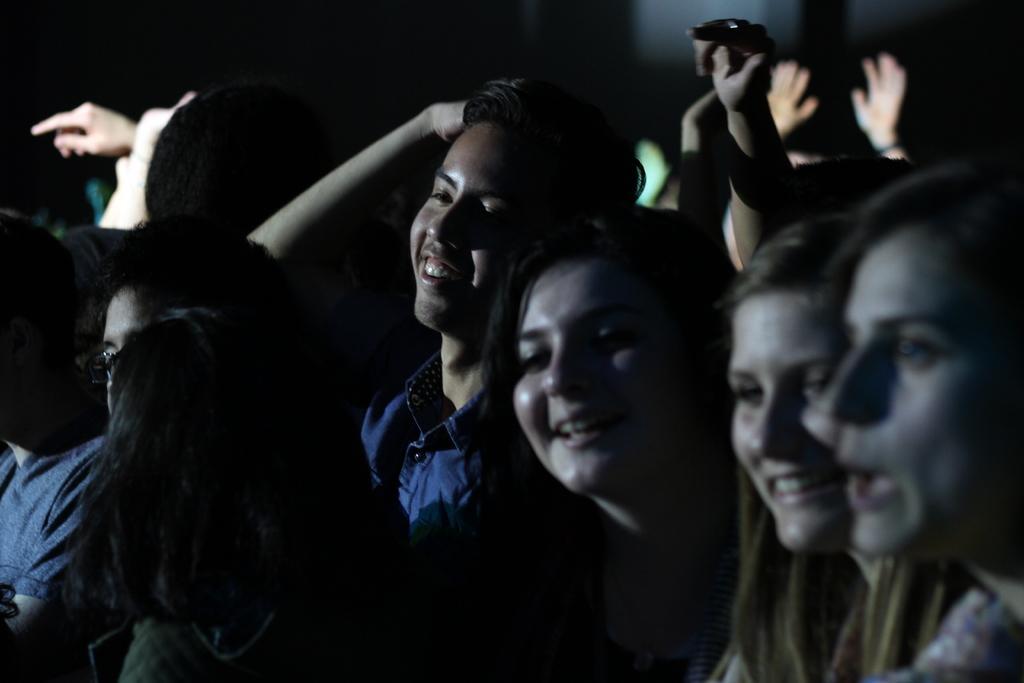How would you summarize this image in a sentence or two? There are people standing and smiling. A person at the center is wearing a blue shirt. 